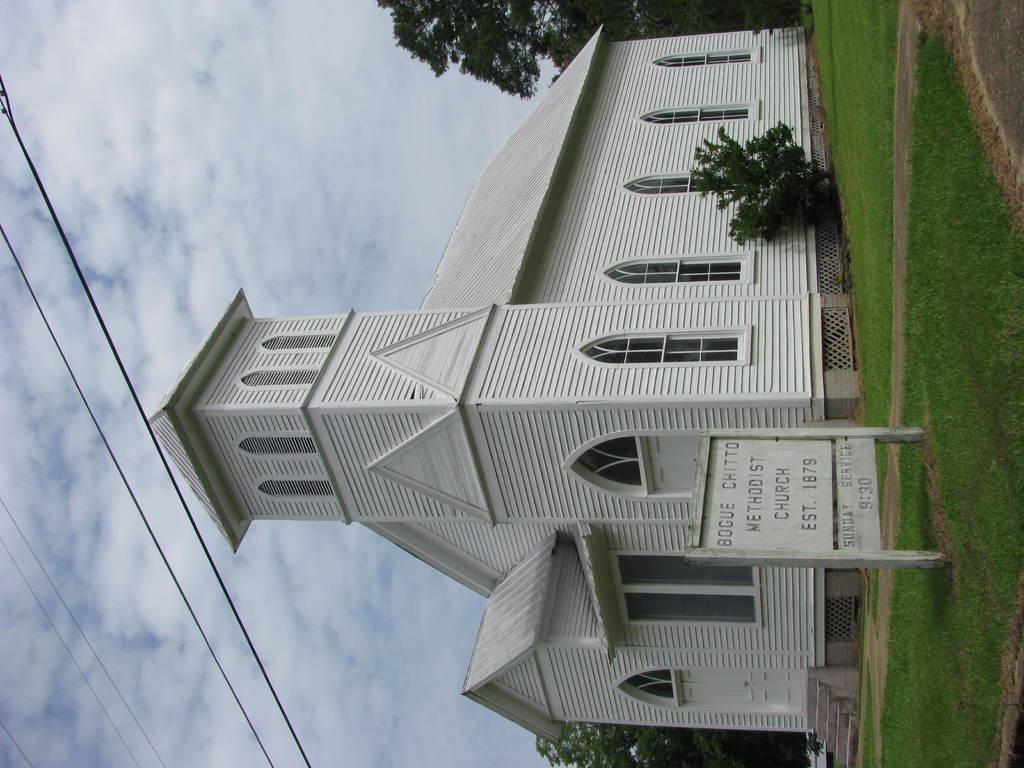Provide a one-sentence caption for the provided image. White church, Bogue chitto methodist church est. 1879. 